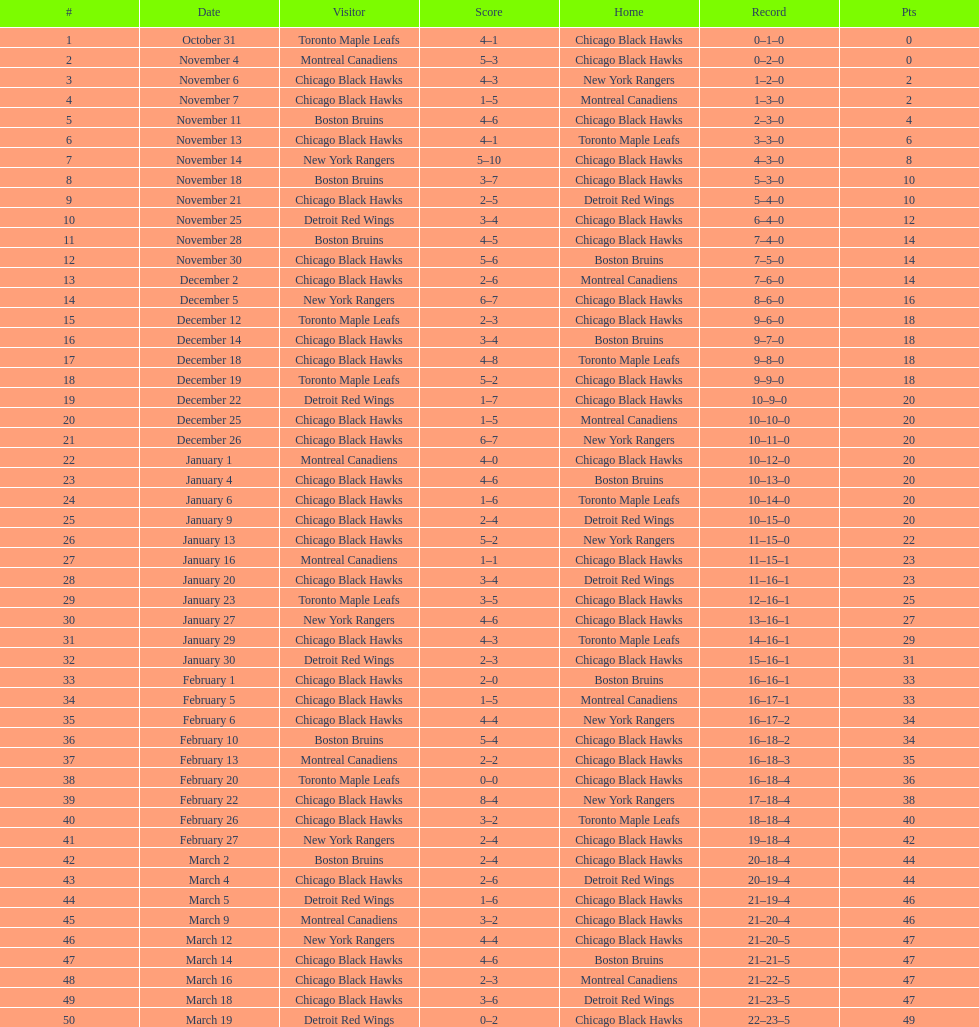On november 4th, what was the cumulative total of points scored? 8. 